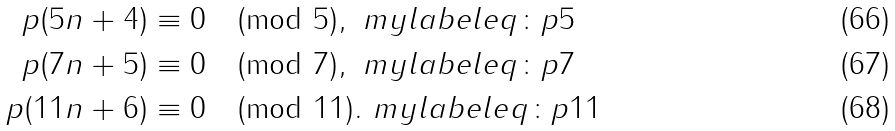<formula> <loc_0><loc_0><loc_500><loc_500>p ( 5 n + 4 ) & \equiv 0 \pmod { 5 } , \ m y l a b e l { e q \colon p 5 } \\ p ( 7 n + 5 ) & \equiv 0 \pmod { 7 } , \ m y l a b e l { e q \colon p 7 } \\ p ( 1 1 n + 6 ) & \equiv 0 \pmod { 1 1 } . \ m y l a b e l { e q \colon p 1 1 }</formula> 